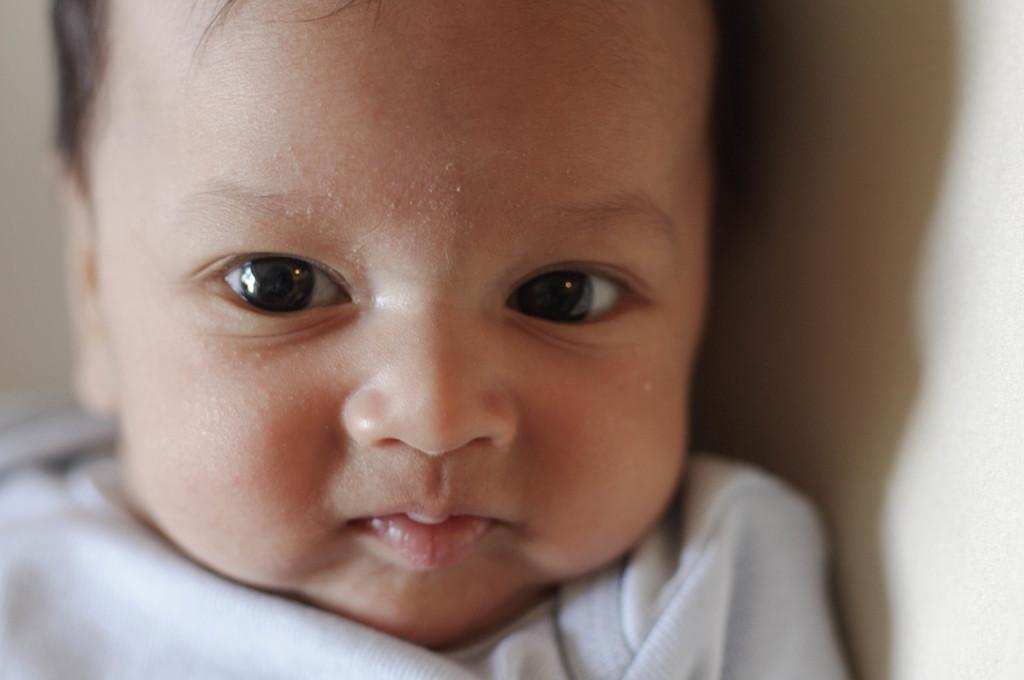What is the main subject of the image? There is a baby in the image. Can you describe the background of the image? The background of the image is blurred. Can you see a stream, tree, or goose in the image? No, there is no stream, tree, or goose present in the image. 